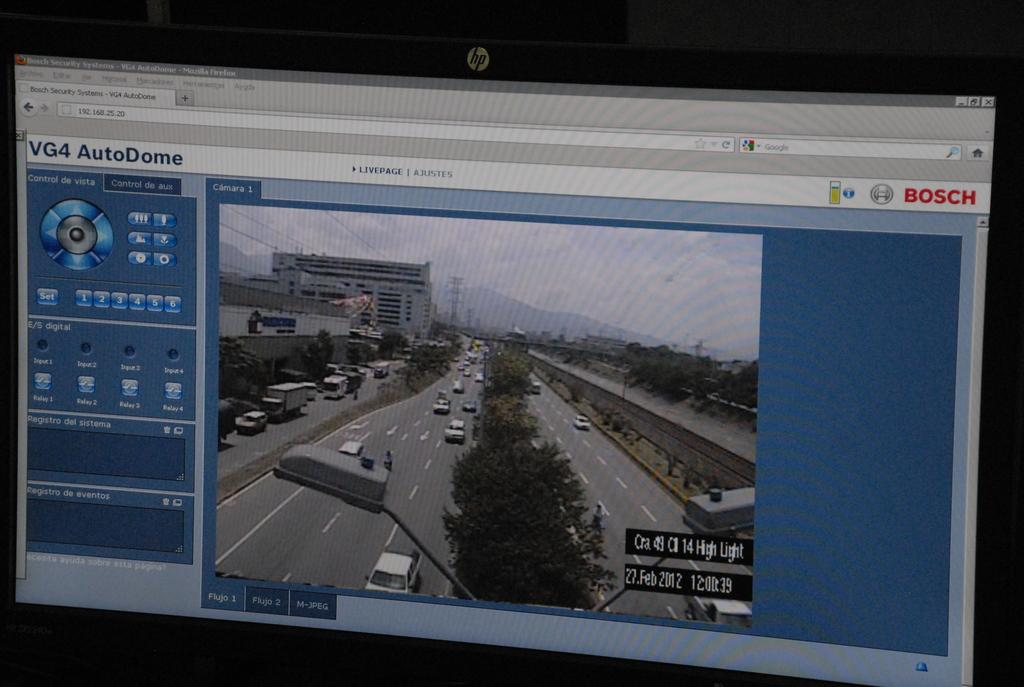<image>
Render a clear and concise summary of the photo. The footage shown of the road was taken on 27 Feb 2012. 